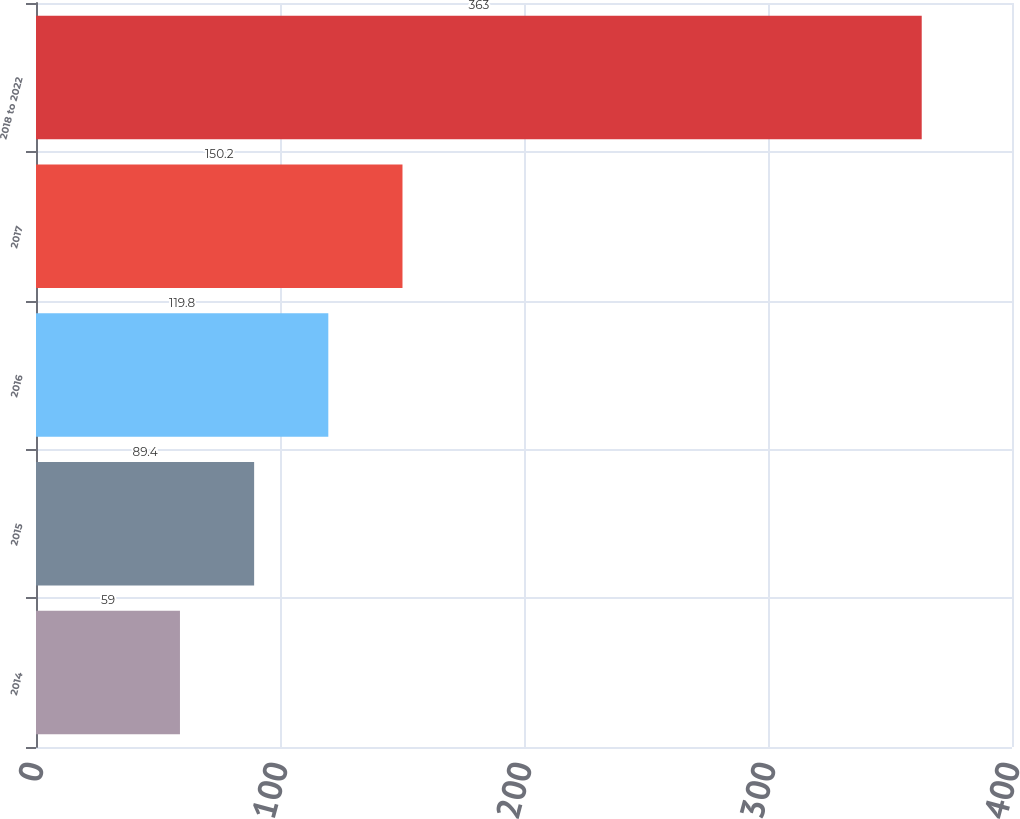<chart> <loc_0><loc_0><loc_500><loc_500><bar_chart><fcel>2014<fcel>2015<fcel>2016<fcel>2017<fcel>2018 to 2022<nl><fcel>59<fcel>89.4<fcel>119.8<fcel>150.2<fcel>363<nl></chart> 